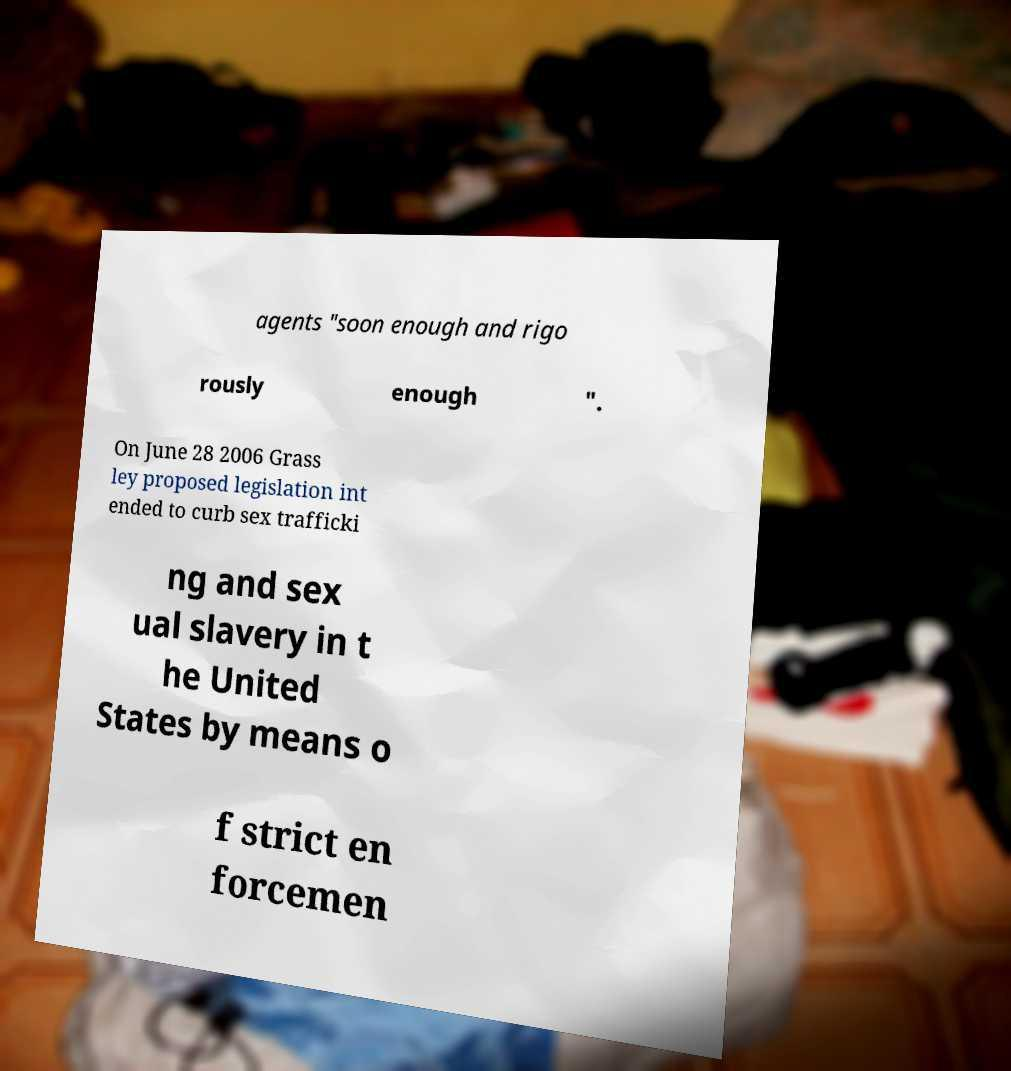Can you accurately transcribe the text from the provided image for me? agents "soon enough and rigo rously enough ". On June 28 2006 Grass ley proposed legislation int ended to curb sex trafficki ng and sex ual slavery in t he United States by means o f strict en forcemen 